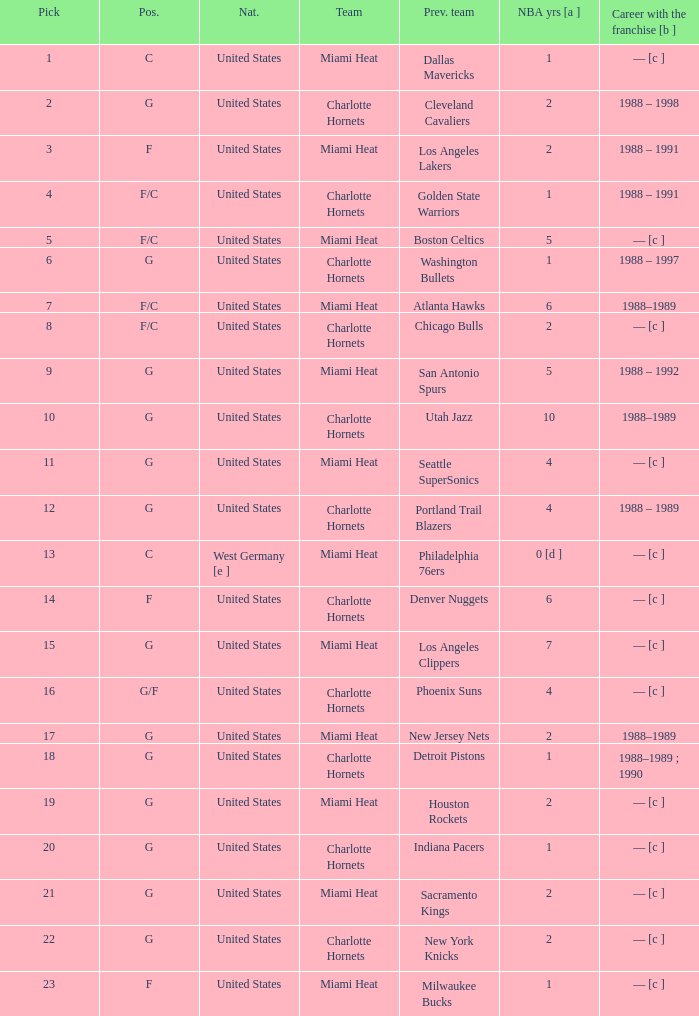How many NBA years did the player from the United States who was previously on the los angeles lakers have? 2.0. 